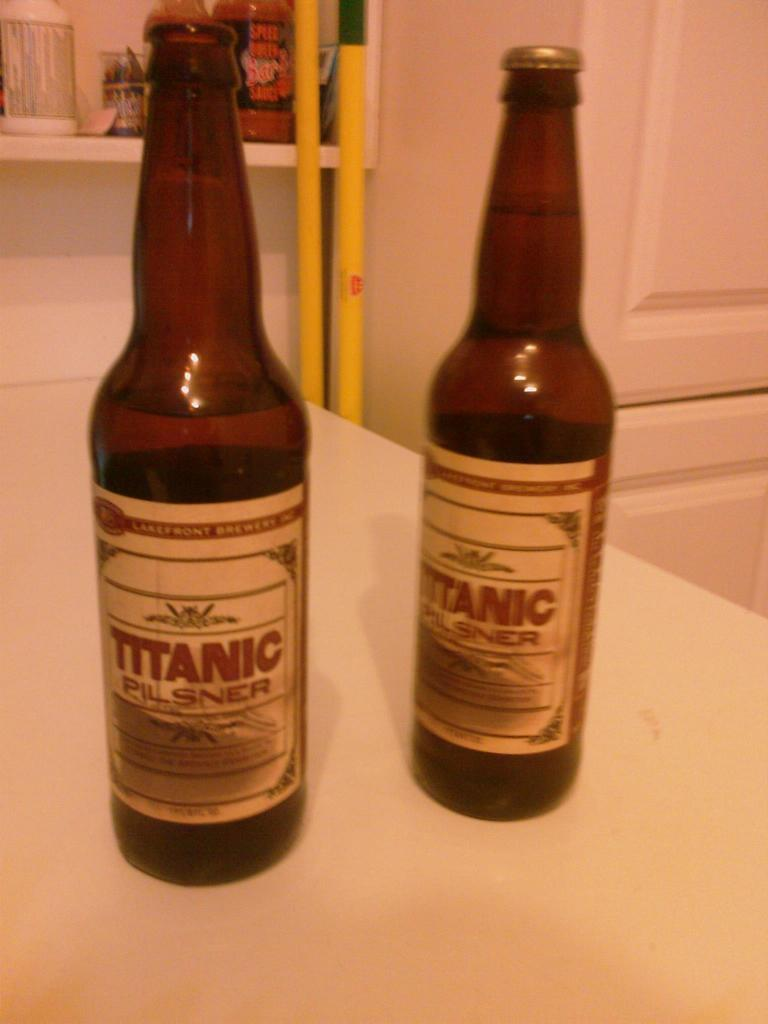<image>
Describe the image concisely. Two brown bottles are labeled Titanic Pilsner beer. 